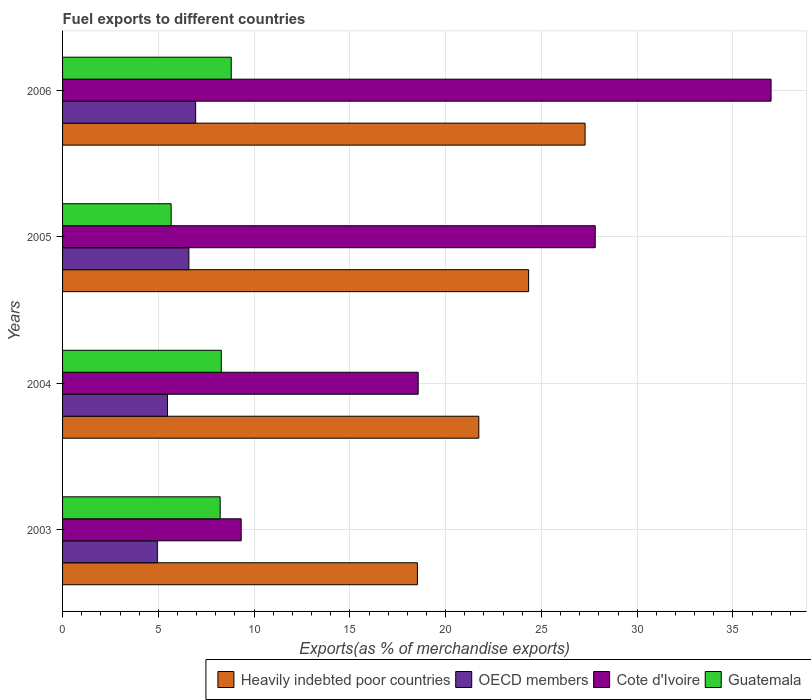How many different coloured bars are there?
Provide a succinct answer. 4. Are the number of bars per tick equal to the number of legend labels?
Ensure brevity in your answer.  Yes. Are the number of bars on each tick of the Y-axis equal?
Provide a short and direct response. Yes. How many bars are there on the 1st tick from the top?
Your answer should be very brief. 4. What is the percentage of exports to different countries in OECD members in 2005?
Ensure brevity in your answer.  6.59. Across all years, what is the maximum percentage of exports to different countries in Guatemala?
Keep it short and to the point. 8.81. Across all years, what is the minimum percentage of exports to different countries in Guatemala?
Your answer should be compact. 5.67. In which year was the percentage of exports to different countries in Cote d'Ivoire maximum?
Keep it short and to the point. 2006. What is the total percentage of exports to different countries in Heavily indebted poor countries in the graph?
Keep it short and to the point. 91.87. What is the difference between the percentage of exports to different countries in OECD members in 2003 and that in 2004?
Provide a succinct answer. -0.53. What is the difference between the percentage of exports to different countries in Cote d'Ivoire in 2004 and the percentage of exports to different countries in Guatemala in 2003?
Offer a terse response. 10.34. What is the average percentage of exports to different countries in OECD members per year?
Your answer should be compact. 5.99. In the year 2004, what is the difference between the percentage of exports to different countries in Cote d'Ivoire and percentage of exports to different countries in OECD members?
Provide a short and direct response. 13.09. In how many years, is the percentage of exports to different countries in Guatemala greater than 8 %?
Your response must be concise. 3. What is the ratio of the percentage of exports to different countries in OECD members in 2003 to that in 2005?
Keep it short and to the point. 0.75. What is the difference between the highest and the second highest percentage of exports to different countries in Heavily indebted poor countries?
Make the answer very short. 2.95. What is the difference between the highest and the lowest percentage of exports to different countries in Cote d'Ivoire?
Provide a succinct answer. 27.66. What does the 1st bar from the top in 2005 represents?
Keep it short and to the point. Guatemala. What does the 3rd bar from the bottom in 2004 represents?
Provide a short and direct response. Cote d'Ivoire. Are all the bars in the graph horizontal?
Your answer should be very brief. Yes. How many years are there in the graph?
Offer a very short reply. 4. What is the difference between two consecutive major ticks on the X-axis?
Your response must be concise. 5. Does the graph contain any zero values?
Provide a succinct answer. No. Does the graph contain grids?
Offer a terse response. Yes. What is the title of the graph?
Keep it short and to the point. Fuel exports to different countries. Does "World" appear as one of the legend labels in the graph?
Provide a short and direct response. No. What is the label or title of the X-axis?
Your response must be concise. Exports(as % of merchandise exports). What is the label or title of the Y-axis?
Your response must be concise. Years. What is the Exports(as % of merchandise exports) in Heavily indebted poor countries in 2003?
Your answer should be compact. 18.52. What is the Exports(as % of merchandise exports) of OECD members in 2003?
Give a very brief answer. 4.95. What is the Exports(as % of merchandise exports) in Cote d'Ivoire in 2003?
Your answer should be compact. 9.33. What is the Exports(as % of merchandise exports) in Guatemala in 2003?
Make the answer very short. 8.23. What is the Exports(as % of merchandise exports) in Heavily indebted poor countries in 2004?
Ensure brevity in your answer.  21.73. What is the Exports(as % of merchandise exports) of OECD members in 2004?
Offer a very short reply. 5.48. What is the Exports(as % of merchandise exports) of Cote d'Ivoire in 2004?
Your answer should be compact. 18.57. What is the Exports(as % of merchandise exports) of Guatemala in 2004?
Ensure brevity in your answer.  8.29. What is the Exports(as % of merchandise exports) of Heavily indebted poor countries in 2005?
Your answer should be very brief. 24.33. What is the Exports(as % of merchandise exports) of OECD members in 2005?
Provide a succinct answer. 6.59. What is the Exports(as % of merchandise exports) in Cote d'Ivoire in 2005?
Your response must be concise. 27.81. What is the Exports(as % of merchandise exports) of Guatemala in 2005?
Your response must be concise. 5.67. What is the Exports(as % of merchandise exports) in Heavily indebted poor countries in 2006?
Keep it short and to the point. 27.28. What is the Exports(as % of merchandise exports) of OECD members in 2006?
Your response must be concise. 6.95. What is the Exports(as % of merchandise exports) in Cote d'Ivoire in 2006?
Offer a very short reply. 36.99. What is the Exports(as % of merchandise exports) in Guatemala in 2006?
Ensure brevity in your answer.  8.81. Across all years, what is the maximum Exports(as % of merchandise exports) in Heavily indebted poor countries?
Ensure brevity in your answer.  27.28. Across all years, what is the maximum Exports(as % of merchandise exports) of OECD members?
Your response must be concise. 6.95. Across all years, what is the maximum Exports(as % of merchandise exports) of Cote d'Ivoire?
Ensure brevity in your answer.  36.99. Across all years, what is the maximum Exports(as % of merchandise exports) in Guatemala?
Provide a short and direct response. 8.81. Across all years, what is the minimum Exports(as % of merchandise exports) of Heavily indebted poor countries?
Your answer should be compact. 18.52. Across all years, what is the minimum Exports(as % of merchandise exports) in OECD members?
Offer a terse response. 4.95. Across all years, what is the minimum Exports(as % of merchandise exports) in Cote d'Ivoire?
Your answer should be very brief. 9.33. Across all years, what is the minimum Exports(as % of merchandise exports) of Guatemala?
Ensure brevity in your answer.  5.67. What is the total Exports(as % of merchandise exports) of Heavily indebted poor countries in the graph?
Offer a very short reply. 91.87. What is the total Exports(as % of merchandise exports) in OECD members in the graph?
Your answer should be very brief. 23.97. What is the total Exports(as % of merchandise exports) of Cote d'Ivoire in the graph?
Your response must be concise. 92.69. What is the total Exports(as % of merchandise exports) of Guatemala in the graph?
Offer a terse response. 30.99. What is the difference between the Exports(as % of merchandise exports) in Heavily indebted poor countries in 2003 and that in 2004?
Give a very brief answer. -3.21. What is the difference between the Exports(as % of merchandise exports) in OECD members in 2003 and that in 2004?
Make the answer very short. -0.53. What is the difference between the Exports(as % of merchandise exports) in Cote d'Ivoire in 2003 and that in 2004?
Offer a terse response. -9.24. What is the difference between the Exports(as % of merchandise exports) in Guatemala in 2003 and that in 2004?
Give a very brief answer. -0.06. What is the difference between the Exports(as % of merchandise exports) of Heavily indebted poor countries in 2003 and that in 2005?
Keep it short and to the point. -5.81. What is the difference between the Exports(as % of merchandise exports) in OECD members in 2003 and that in 2005?
Provide a short and direct response. -1.65. What is the difference between the Exports(as % of merchandise exports) in Cote d'Ivoire in 2003 and that in 2005?
Your answer should be compact. -18.48. What is the difference between the Exports(as % of merchandise exports) of Guatemala in 2003 and that in 2005?
Your answer should be compact. 2.56. What is the difference between the Exports(as % of merchandise exports) in Heavily indebted poor countries in 2003 and that in 2006?
Your response must be concise. -8.75. What is the difference between the Exports(as % of merchandise exports) in OECD members in 2003 and that in 2006?
Give a very brief answer. -2. What is the difference between the Exports(as % of merchandise exports) of Cote d'Ivoire in 2003 and that in 2006?
Ensure brevity in your answer.  -27.66. What is the difference between the Exports(as % of merchandise exports) of Guatemala in 2003 and that in 2006?
Your answer should be very brief. -0.58. What is the difference between the Exports(as % of merchandise exports) of Heavily indebted poor countries in 2004 and that in 2005?
Ensure brevity in your answer.  -2.6. What is the difference between the Exports(as % of merchandise exports) of OECD members in 2004 and that in 2005?
Keep it short and to the point. -1.12. What is the difference between the Exports(as % of merchandise exports) in Cote d'Ivoire in 2004 and that in 2005?
Your response must be concise. -9.24. What is the difference between the Exports(as % of merchandise exports) in Guatemala in 2004 and that in 2005?
Provide a short and direct response. 2.62. What is the difference between the Exports(as % of merchandise exports) of Heavily indebted poor countries in 2004 and that in 2006?
Make the answer very short. -5.55. What is the difference between the Exports(as % of merchandise exports) in OECD members in 2004 and that in 2006?
Provide a short and direct response. -1.47. What is the difference between the Exports(as % of merchandise exports) in Cote d'Ivoire in 2004 and that in 2006?
Offer a terse response. -18.42. What is the difference between the Exports(as % of merchandise exports) of Guatemala in 2004 and that in 2006?
Give a very brief answer. -0.52. What is the difference between the Exports(as % of merchandise exports) in Heavily indebted poor countries in 2005 and that in 2006?
Give a very brief answer. -2.95. What is the difference between the Exports(as % of merchandise exports) in OECD members in 2005 and that in 2006?
Ensure brevity in your answer.  -0.35. What is the difference between the Exports(as % of merchandise exports) of Cote d'Ivoire in 2005 and that in 2006?
Make the answer very short. -9.18. What is the difference between the Exports(as % of merchandise exports) of Guatemala in 2005 and that in 2006?
Your answer should be compact. -3.14. What is the difference between the Exports(as % of merchandise exports) in Heavily indebted poor countries in 2003 and the Exports(as % of merchandise exports) in OECD members in 2004?
Ensure brevity in your answer.  13.05. What is the difference between the Exports(as % of merchandise exports) in Heavily indebted poor countries in 2003 and the Exports(as % of merchandise exports) in Cote d'Ivoire in 2004?
Keep it short and to the point. -0.04. What is the difference between the Exports(as % of merchandise exports) in Heavily indebted poor countries in 2003 and the Exports(as % of merchandise exports) in Guatemala in 2004?
Provide a succinct answer. 10.24. What is the difference between the Exports(as % of merchandise exports) of OECD members in 2003 and the Exports(as % of merchandise exports) of Cote d'Ivoire in 2004?
Provide a succinct answer. -13.62. What is the difference between the Exports(as % of merchandise exports) of OECD members in 2003 and the Exports(as % of merchandise exports) of Guatemala in 2004?
Make the answer very short. -3.34. What is the difference between the Exports(as % of merchandise exports) of Cote d'Ivoire in 2003 and the Exports(as % of merchandise exports) of Guatemala in 2004?
Keep it short and to the point. 1.04. What is the difference between the Exports(as % of merchandise exports) of Heavily indebted poor countries in 2003 and the Exports(as % of merchandise exports) of OECD members in 2005?
Offer a very short reply. 11.93. What is the difference between the Exports(as % of merchandise exports) of Heavily indebted poor countries in 2003 and the Exports(as % of merchandise exports) of Cote d'Ivoire in 2005?
Keep it short and to the point. -9.28. What is the difference between the Exports(as % of merchandise exports) in Heavily indebted poor countries in 2003 and the Exports(as % of merchandise exports) in Guatemala in 2005?
Give a very brief answer. 12.86. What is the difference between the Exports(as % of merchandise exports) of OECD members in 2003 and the Exports(as % of merchandise exports) of Cote d'Ivoire in 2005?
Your answer should be compact. -22.86. What is the difference between the Exports(as % of merchandise exports) of OECD members in 2003 and the Exports(as % of merchandise exports) of Guatemala in 2005?
Ensure brevity in your answer.  -0.72. What is the difference between the Exports(as % of merchandise exports) in Cote d'Ivoire in 2003 and the Exports(as % of merchandise exports) in Guatemala in 2005?
Provide a short and direct response. 3.66. What is the difference between the Exports(as % of merchandise exports) of Heavily indebted poor countries in 2003 and the Exports(as % of merchandise exports) of OECD members in 2006?
Provide a short and direct response. 11.58. What is the difference between the Exports(as % of merchandise exports) of Heavily indebted poor countries in 2003 and the Exports(as % of merchandise exports) of Cote d'Ivoire in 2006?
Your answer should be very brief. -18.46. What is the difference between the Exports(as % of merchandise exports) in Heavily indebted poor countries in 2003 and the Exports(as % of merchandise exports) in Guatemala in 2006?
Provide a succinct answer. 9.72. What is the difference between the Exports(as % of merchandise exports) in OECD members in 2003 and the Exports(as % of merchandise exports) in Cote d'Ivoire in 2006?
Keep it short and to the point. -32.04. What is the difference between the Exports(as % of merchandise exports) in OECD members in 2003 and the Exports(as % of merchandise exports) in Guatemala in 2006?
Your answer should be compact. -3.86. What is the difference between the Exports(as % of merchandise exports) of Cote d'Ivoire in 2003 and the Exports(as % of merchandise exports) of Guatemala in 2006?
Your answer should be compact. 0.52. What is the difference between the Exports(as % of merchandise exports) in Heavily indebted poor countries in 2004 and the Exports(as % of merchandise exports) in OECD members in 2005?
Give a very brief answer. 15.14. What is the difference between the Exports(as % of merchandise exports) of Heavily indebted poor countries in 2004 and the Exports(as % of merchandise exports) of Cote d'Ivoire in 2005?
Provide a short and direct response. -6.08. What is the difference between the Exports(as % of merchandise exports) of Heavily indebted poor countries in 2004 and the Exports(as % of merchandise exports) of Guatemala in 2005?
Your answer should be very brief. 16.06. What is the difference between the Exports(as % of merchandise exports) in OECD members in 2004 and the Exports(as % of merchandise exports) in Cote d'Ivoire in 2005?
Provide a short and direct response. -22.33. What is the difference between the Exports(as % of merchandise exports) of OECD members in 2004 and the Exports(as % of merchandise exports) of Guatemala in 2005?
Make the answer very short. -0.19. What is the difference between the Exports(as % of merchandise exports) in Cote d'Ivoire in 2004 and the Exports(as % of merchandise exports) in Guatemala in 2005?
Your answer should be very brief. 12.9. What is the difference between the Exports(as % of merchandise exports) in Heavily indebted poor countries in 2004 and the Exports(as % of merchandise exports) in OECD members in 2006?
Your answer should be compact. 14.78. What is the difference between the Exports(as % of merchandise exports) of Heavily indebted poor countries in 2004 and the Exports(as % of merchandise exports) of Cote d'Ivoire in 2006?
Keep it short and to the point. -15.26. What is the difference between the Exports(as % of merchandise exports) of Heavily indebted poor countries in 2004 and the Exports(as % of merchandise exports) of Guatemala in 2006?
Your answer should be compact. 12.93. What is the difference between the Exports(as % of merchandise exports) of OECD members in 2004 and the Exports(as % of merchandise exports) of Cote d'Ivoire in 2006?
Provide a short and direct response. -31.51. What is the difference between the Exports(as % of merchandise exports) in OECD members in 2004 and the Exports(as % of merchandise exports) in Guatemala in 2006?
Make the answer very short. -3.33. What is the difference between the Exports(as % of merchandise exports) in Cote d'Ivoire in 2004 and the Exports(as % of merchandise exports) in Guatemala in 2006?
Your answer should be very brief. 9.76. What is the difference between the Exports(as % of merchandise exports) of Heavily indebted poor countries in 2005 and the Exports(as % of merchandise exports) of OECD members in 2006?
Your answer should be compact. 17.38. What is the difference between the Exports(as % of merchandise exports) of Heavily indebted poor countries in 2005 and the Exports(as % of merchandise exports) of Cote d'Ivoire in 2006?
Your response must be concise. -12.66. What is the difference between the Exports(as % of merchandise exports) in Heavily indebted poor countries in 2005 and the Exports(as % of merchandise exports) in Guatemala in 2006?
Ensure brevity in your answer.  15.53. What is the difference between the Exports(as % of merchandise exports) in OECD members in 2005 and the Exports(as % of merchandise exports) in Cote d'Ivoire in 2006?
Your response must be concise. -30.39. What is the difference between the Exports(as % of merchandise exports) of OECD members in 2005 and the Exports(as % of merchandise exports) of Guatemala in 2006?
Offer a terse response. -2.21. What is the difference between the Exports(as % of merchandise exports) of Cote d'Ivoire in 2005 and the Exports(as % of merchandise exports) of Guatemala in 2006?
Make the answer very short. 19. What is the average Exports(as % of merchandise exports) of Heavily indebted poor countries per year?
Provide a short and direct response. 22.97. What is the average Exports(as % of merchandise exports) of OECD members per year?
Your answer should be compact. 5.99. What is the average Exports(as % of merchandise exports) in Cote d'Ivoire per year?
Give a very brief answer. 23.17. What is the average Exports(as % of merchandise exports) of Guatemala per year?
Keep it short and to the point. 7.75. In the year 2003, what is the difference between the Exports(as % of merchandise exports) in Heavily indebted poor countries and Exports(as % of merchandise exports) in OECD members?
Your response must be concise. 13.58. In the year 2003, what is the difference between the Exports(as % of merchandise exports) of Heavily indebted poor countries and Exports(as % of merchandise exports) of Cote d'Ivoire?
Ensure brevity in your answer.  9.2. In the year 2003, what is the difference between the Exports(as % of merchandise exports) in Heavily indebted poor countries and Exports(as % of merchandise exports) in Guatemala?
Provide a succinct answer. 10.3. In the year 2003, what is the difference between the Exports(as % of merchandise exports) of OECD members and Exports(as % of merchandise exports) of Cote d'Ivoire?
Your answer should be very brief. -4.38. In the year 2003, what is the difference between the Exports(as % of merchandise exports) in OECD members and Exports(as % of merchandise exports) in Guatemala?
Your response must be concise. -3.28. In the year 2003, what is the difference between the Exports(as % of merchandise exports) of Cote d'Ivoire and Exports(as % of merchandise exports) of Guatemala?
Your answer should be compact. 1.1. In the year 2004, what is the difference between the Exports(as % of merchandise exports) in Heavily indebted poor countries and Exports(as % of merchandise exports) in OECD members?
Provide a short and direct response. 16.25. In the year 2004, what is the difference between the Exports(as % of merchandise exports) of Heavily indebted poor countries and Exports(as % of merchandise exports) of Cote d'Ivoire?
Offer a very short reply. 3.17. In the year 2004, what is the difference between the Exports(as % of merchandise exports) of Heavily indebted poor countries and Exports(as % of merchandise exports) of Guatemala?
Make the answer very short. 13.44. In the year 2004, what is the difference between the Exports(as % of merchandise exports) in OECD members and Exports(as % of merchandise exports) in Cote d'Ivoire?
Provide a short and direct response. -13.09. In the year 2004, what is the difference between the Exports(as % of merchandise exports) of OECD members and Exports(as % of merchandise exports) of Guatemala?
Provide a succinct answer. -2.81. In the year 2004, what is the difference between the Exports(as % of merchandise exports) of Cote d'Ivoire and Exports(as % of merchandise exports) of Guatemala?
Provide a succinct answer. 10.28. In the year 2005, what is the difference between the Exports(as % of merchandise exports) of Heavily indebted poor countries and Exports(as % of merchandise exports) of OECD members?
Provide a short and direct response. 17.74. In the year 2005, what is the difference between the Exports(as % of merchandise exports) in Heavily indebted poor countries and Exports(as % of merchandise exports) in Cote d'Ivoire?
Give a very brief answer. -3.48. In the year 2005, what is the difference between the Exports(as % of merchandise exports) of Heavily indebted poor countries and Exports(as % of merchandise exports) of Guatemala?
Make the answer very short. 18.66. In the year 2005, what is the difference between the Exports(as % of merchandise exports) in OECD members and Exports(as % of merchandise exports) in Cote d'Ivoire?
Offer a very short reply. -21.21. In the year 2005, what is the difference between the Exports(as % of merchandise exports) of OECD members and Exports(as % of merchandise exports) of Guatemala?
Provide a succinct answer. 0.93. In the year 2005, what is the difference between the Exports(as % of merchandise exports) of Cote d'Ivoire and Exports(as % of merchandise exports) of Guatemala?
Ensure brevity in your answer.  22.14. In the year 2006, what is the difference between the Exports(as % of merchandise exports) of Heavily indebted poor countries and Exports(as % of merchandise exports) of OECD members?
Your response must be concise. 20.33. In the year 2006, what is the difference between the Exports(as % of merchandise exports) in Heavily indebted poor countries and Exports(as % of merchandise exports) in Cote d'Ivoire?
Offer a terse response. -9.71. In the year 2006, what is the difference between the Exports(as % of merchandise exports) in Heavily indebted poor countries and Exports(as % of merchandise exports) in Guatemala?
Give a very brief answer. 18.47. In the year 2006, what is the difference between the Exports(as % of merchandise exports) in OECD members and Exports(as % of merchandise exports) in Cote d'Ivoire?
Provide a short and direct response. -30.04. In the year 2006, what is the difference between the Exports(as % of merchandise exports) in OECD members and Exports(as % of merchandise exports) in Guatemala?
Ensure brevity in your answer.  -1.86. In the year 2006, what is the difference between the Exports(as % of merchandise exports) of Cote d'Ivoire and Exports(as % of merchandise exports) of Guatemala?
Ensure brevity in your answer.  28.18. What is the ratio of the Exports(as % of merchandise exports) in Heavily indebted poor countries in 2003 to that in 2004?
Keep it short and to the point. 0.85. What is the ratio of the Exports(as % of merchandise exports) of OECD members in 2003 to that in 2004?
Give a very brief answer. 0.9. What is the ratio of the Exports(as % of merchandise exports) of Cote d'Ivoire in 2003 to that in 2004?
Keep it short and to the point. 0.5. What is the ratio of the Exports(as % of merchandise exports) in Heavily indebted poor countries in 2003 to that in 2005?
Ensure brevity in your answer.  0.76. What is the ratio of the Exports(as % of merchandise exports) of OECD members in 2003 to that in 2005?
Your answer should be compact. 0.75. What is the ratio of the Exports(as % of merchandise exports) in Cote d'Ivoire in 2003 to that in 2005?
Make the answer very short. 0.34. What is the ratio of the Exports(as % of merchandise exports) in Guatemala in 2003 to that in 2005?
Provide a succinct answer. 1.45. What is the ratio of the Exports(as % of merchandise exports) of Heavily indebted poor countries in 2003 to that in 2006?
Your answer should be compact. 0.68. What is the ratio of the Exports(as % of merchandise exports) in OECD members in 2003 to that in 2006?
Your response must be concise. 0.71. What is the ratio of the Exports(as % of merchandise exports) in Cote d'Ivoire in 2003 to that in 2006?
Keep it short and to the point. 0.25. What is the ratio of the Exports(as % of merchandise exports) of Guatemala in 2003 to that in 2006?
Your response must be concise. 0.93. What is the ratio of the Exports(as % of merchandise exports) of Heavily indebted poor countries in 2004 to that in 2005?
Give a very brief answer. 0.89. What is the ratio of the Exports(as % of merchandise exports) in OECD members in 2004 to that in 2005?
Offer a very short reply. 0.83. What is the ratio of the Exports(as % of merchandise exports) in Cote d'Ivoire in 2004 to that in 2005?
Make the answer very short. 0.67. What is the ratio of the Exports(as % of merchandise exports) of Guatemala in 2004 to that in 2005?
Offer a terse response. 1.46. What is the ratio of the Exports(as % of merchandise exports) of Heavily indebted poor countries in 2004 to that in 2006?
Keep it short and to the point. 0.8. What is the ratio of the Exports(as % of merchandise exports) in OECD members in 2004 to that in 2006?
Make the answer very short. 0.79. What is the ratio of the Exports(as % of merchandise exports) in Cote d'Ivoire in 2004 to that in 2006?
Give a very brief answer. 0.5. What is the ratio of the Exports(as % of merchandise exports) of Guatemala in 2004 to that in 2006?
Ensure brevity in your answer.  0.94. What is the ratio of the Exports(as % of merchandise exports) of Heavily indebted poor countries in 2005 to that in 2006?
Offer a very short reply. 0.89. What is the ratio of the Exports(as % of merchandise exports) in OECD members in 2005 to that in 2006?
Your answer should be very brief. 0.95. What is the ratio of the Exports(as % of merchandise exports) of Cote d'Ivoire in 2005 to that in 2006?
Your response must be concise. 0.75. What is the ratio of the Exports(as % of merchandise exports) of Guatemala in 2005 to that in 2006?
Offer a very short reply. 0.64. What is the difference between the highest and the second highest Exports(as % of merchandise exports) of Heavily indebted poor countries?
Your response must be concise. 2.95. What is the difference between the highest and the second highest Exports(as % of merchandise exports) of OECD members?
Your answer should be compact. 0.35. What is the difference between the highest and the second highest Exports(as % of merchandise exports) in Cote d'Ivoire?
Ensure brevity in your answer.  9.18. What is the difference between the highest and the second highest Exports(as % of merchandise exports) in Guatemala?
Keep it short and to the point. 0.52. What is the difference between the highest and the lowest Exports(as % of merchandise exports) of Heavily indebted poor countries?
Your answer should be compact. 8.75. What is the difference between the highest and the lowest Exports(as % of merchandise exports) of OECD members?
Your answer should be compact. 2. What is the difference between the highest and the lowest Exports(as % of merchandise exports) of Cote d'Ivoire?
Provide a succinct answer. 27.66. What is the difference between the highest and the lowest Exports(as % of merchandise exports) in Guatemala?
Your response must be concise. 3.14. 